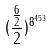Convert formula to latex. <formula><loc_0><loc_0><loc_500><loc_500>( \frac { \frac { 6 } { 2 } } { 2 } ) ^ { 8 ^ { 4 5 3 } }</formula> 